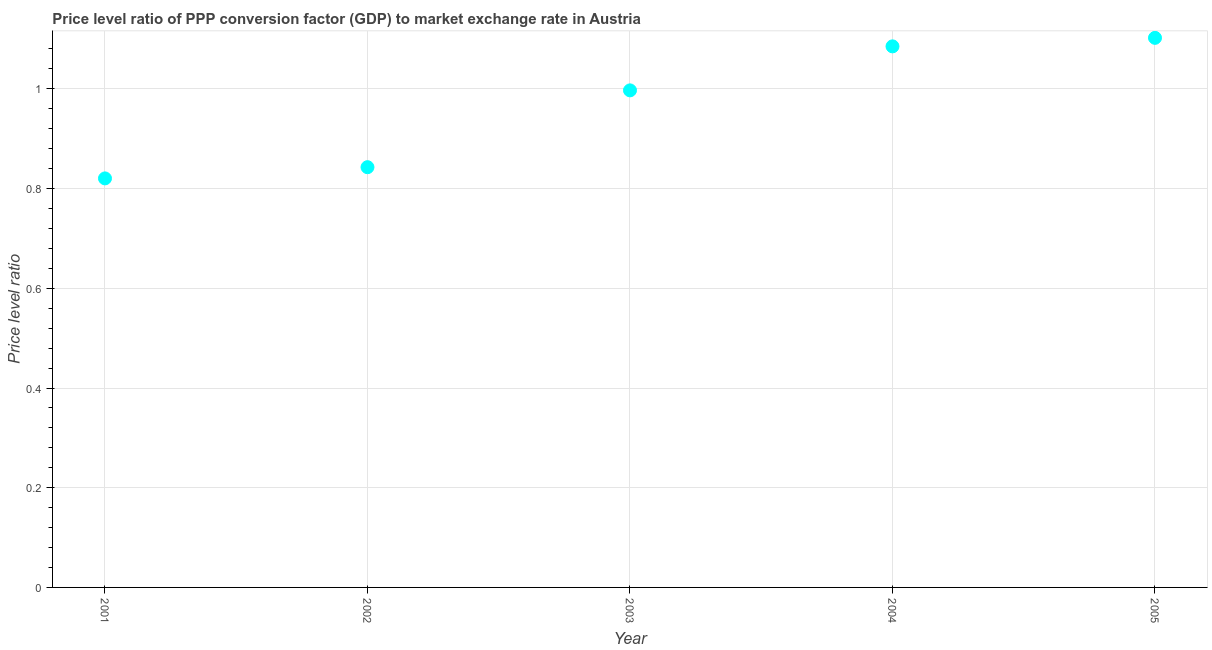What is the price level ratio in 2002?
Ensure brevity in your answer.  0.84. Across all years, what is the maximum price level ratio?
Keep it short and to the point. 1.1. Across all years, what is the minimum price level ratio?
Keep it short and to the point. 0.82. What is the sum of the price level ratio?
Give a very brief answer. 4.85. What is the difference between the price level ratio in 2002 and 2004?
Give a very brief answer. -0.24. What is the average price level ratio per year?
Give a very brief answer. 0.97. What is the median price level ratio?
Your response must be concise. 1. What is the ratio of the price level ratio in 2004 to that in 2005?
Your response must be concise. 0.98. Is the difference between the price level ratio in 2002 and 2005 greater than the difference between any two years?
Your answer should be very brief. No. What is the difference between the highest and the second highest price level ratio?
Provide a succinct answer. 0.02. Is the sum of the price level ratio in 2002 and 2004 greater than the maximum price level ratio across all years?
Offer a very short reply. Yes. What is the difference between the highest and the lowest price level ratio?
Ensure brevity in your answer.  0.28. In how many years, is the price level ratio greater than the average price level ratio taken over all years?
Provide a succinct answer. 3. How many years are there in the graph?
Keep it short and to the point. 5. What is the difference between two consecutive major ticks on the Y-axis?
Provide a short and direct response. 0.2. Does the graph contain any zero values?
Your answer should be very brief. No. Does the graph contain grids?
Ensure brevity in your answer.  Yes. What is the title of the graph?
Your answer should be very brief. Price level ratio of PPP conversion factor (GDP) to market exchange rate in Austria. What is the label or title of the Y-axis?
Your answer should be very brief. Price level ratio. What is the Price level ratio in 2001?
Your answer should be compact. 0.82. What is the Price level ratio in 2002?
Your response must be concise. 0.84. What is the Price level ratio in 2003?
Keep it short and to the point. 1. What is the Price level ratio in 2004?
Your answer should be very brief. 1.09. What is the Price level ratio in 2005?
Keep it short and to the point. 1.1. What is the difference between the Price level ratio in 2001 and 2002?
Offer a terse response. -0.02. What is the difference between the Price level ratio in 2001 and 2003?
Offer a very short reply. -0.18. What is the difference between the Price level ratio in 2001 and 2004?
Provide a succinct answer. -0.26. What is the difference between the Price level ratio in 2001 and 2005?
Make the answer very short. -0.28. What is the difference between the Price level ratio in 2002 and 2003?
Your response must be concise. -0.15. What is the difference between the Price level ratio in 2002 and 2004?
Offer a very short reply. -0.24. What is the difference between the Price level ratio in 2002 and 2005?
Keep it short and to the point. -0.26. What is the difference between the Price level ratio in 2003 and 2004?
Provide a succinct answer. -0.09. What is the difference between the Price level ratio in 2003 and 2005?
Provide a succinct answer. -0.11. What is the difference between the Price level ratio in 2004 and 2005?
Your response must be concise. -0.02. What is the ratio of the Price level ratio in 2001 to that in 2002?
Your response must be concise. 0.97. What is the ratio of the Price level ratio in 2001 to that in 2003?
Your answer should be compact. 0.82. What is the ratio of the Price level ratio in 2001 to that in 2004?
Make the answer very short. 0.76. What is the ratio of the Price level ratio in 2001 to that in 2005?
Your answer should be compact. 0.74. What is the ratio of the Price level ratio in 2002 to that in 2003?
Your answer should be compact. 0.84. What is the ratio of the Price level ratio in 2002 to that in 2004?
Provide a succinct answer. 0.78. What is the ratio of the Price level ratio in 2002 to that in 2005?
Offer a very short reply. 0.77. What is the ratio of the Price level ratio in 2003 to that in 2004?
Offer a terse response. 0.92. What is the ratio of the Price level ratio in 2003 to that in 2005?
Your answer should be very brief. 0.9. 